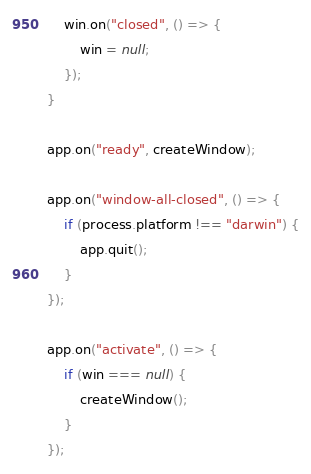<code> <loc_0><loc_0><loc_500><loc_500><_TypeScript_>    win.on("closed", () => {
        win = null;
    });
}

app.on("ready", createWindow);

app.on("window-all-closed", () => {
    if (process.platform !== "darwin") {
        app.quit();
    }
});

app.on("activate", () => {
    if (win === null) {
        createWindow();
    }
});
</code> 